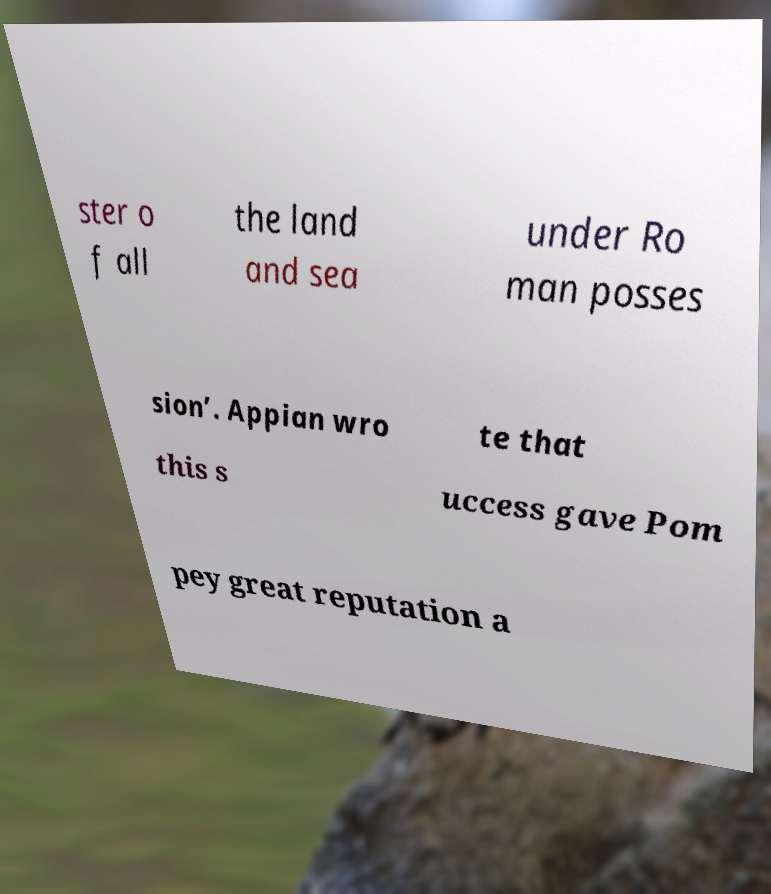Can you read and provide the text displayed in the image?This photo seems to have some interesting text. Can you extract and type it out for me? ster o f all the land and sea under Ro man posses sion’. Appian wro te that this s uccess gave Pom pey great reputation a 